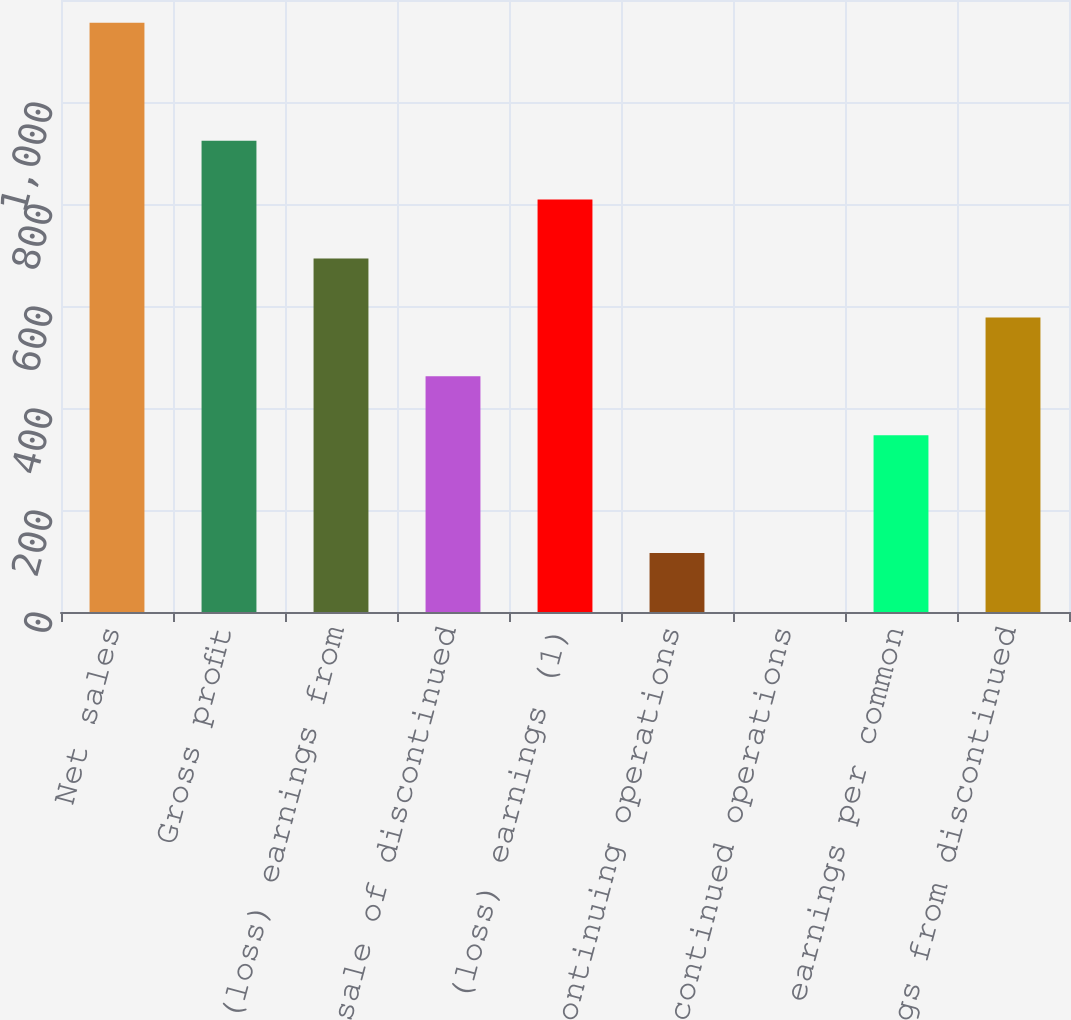Convert chart to OTSL. <chart><loc_0><loc_0><loc_500><loc_500><bar_chart><fcel>Net sales<fcel>Gross profit<fcel>Net (loss) earnings from<fcel>Gain on sale of discontinued<fcel>Net (loss) earnings (1)<fcel>Continuing operations<fcel>Discontinued operations<fcel>Net (loss) earnings per common<fcel>Net earnings from discontinued<nl><fcel>1155.2<fcel>924.19<fcel>693.19<fcel>462.19<fcel>808.69<fcel>115.69<fcel>0.19<fcel>346.69<fcel>577.69<nl></chart> 